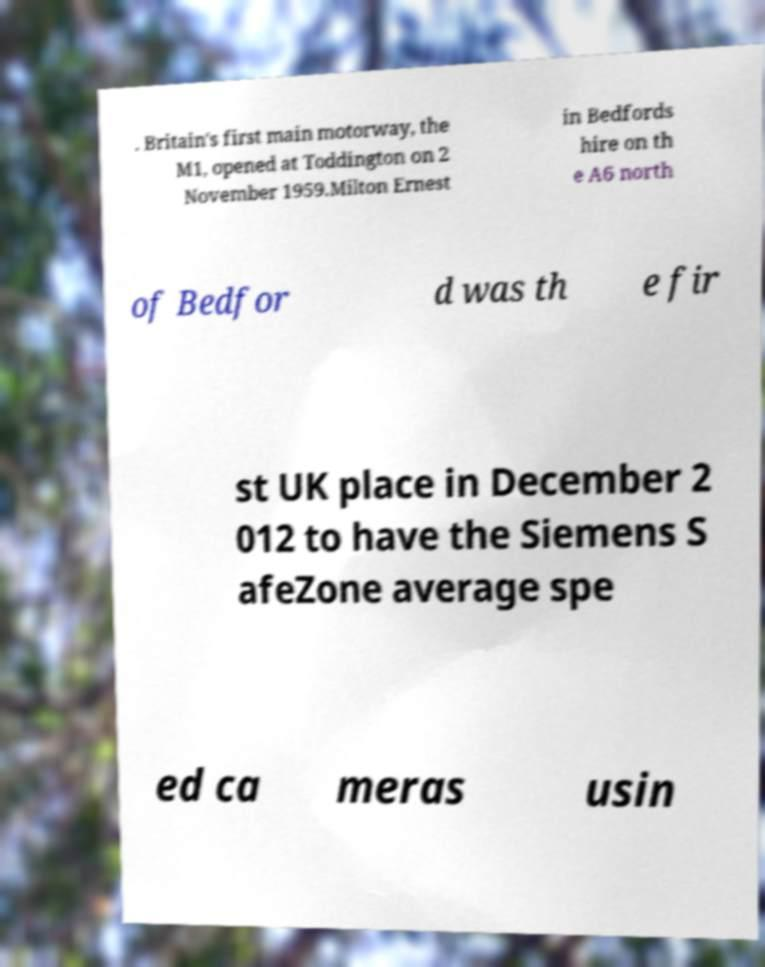I need the written content from this picture converted into text. Can you do that? . Britain's first main motorway, the M1, opened at Toddington on 2 November 1959.Milton Ernest in Bedfords hire on th e A6 north of Bedfor d was th e fir st UK place in December 2 012 to have the Siemens S afeZone average spe ed ca meras usin 